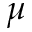Convert formula to latex. <formula><loc_0><loc_0><loc_500><loc_500>\mu</formula> 